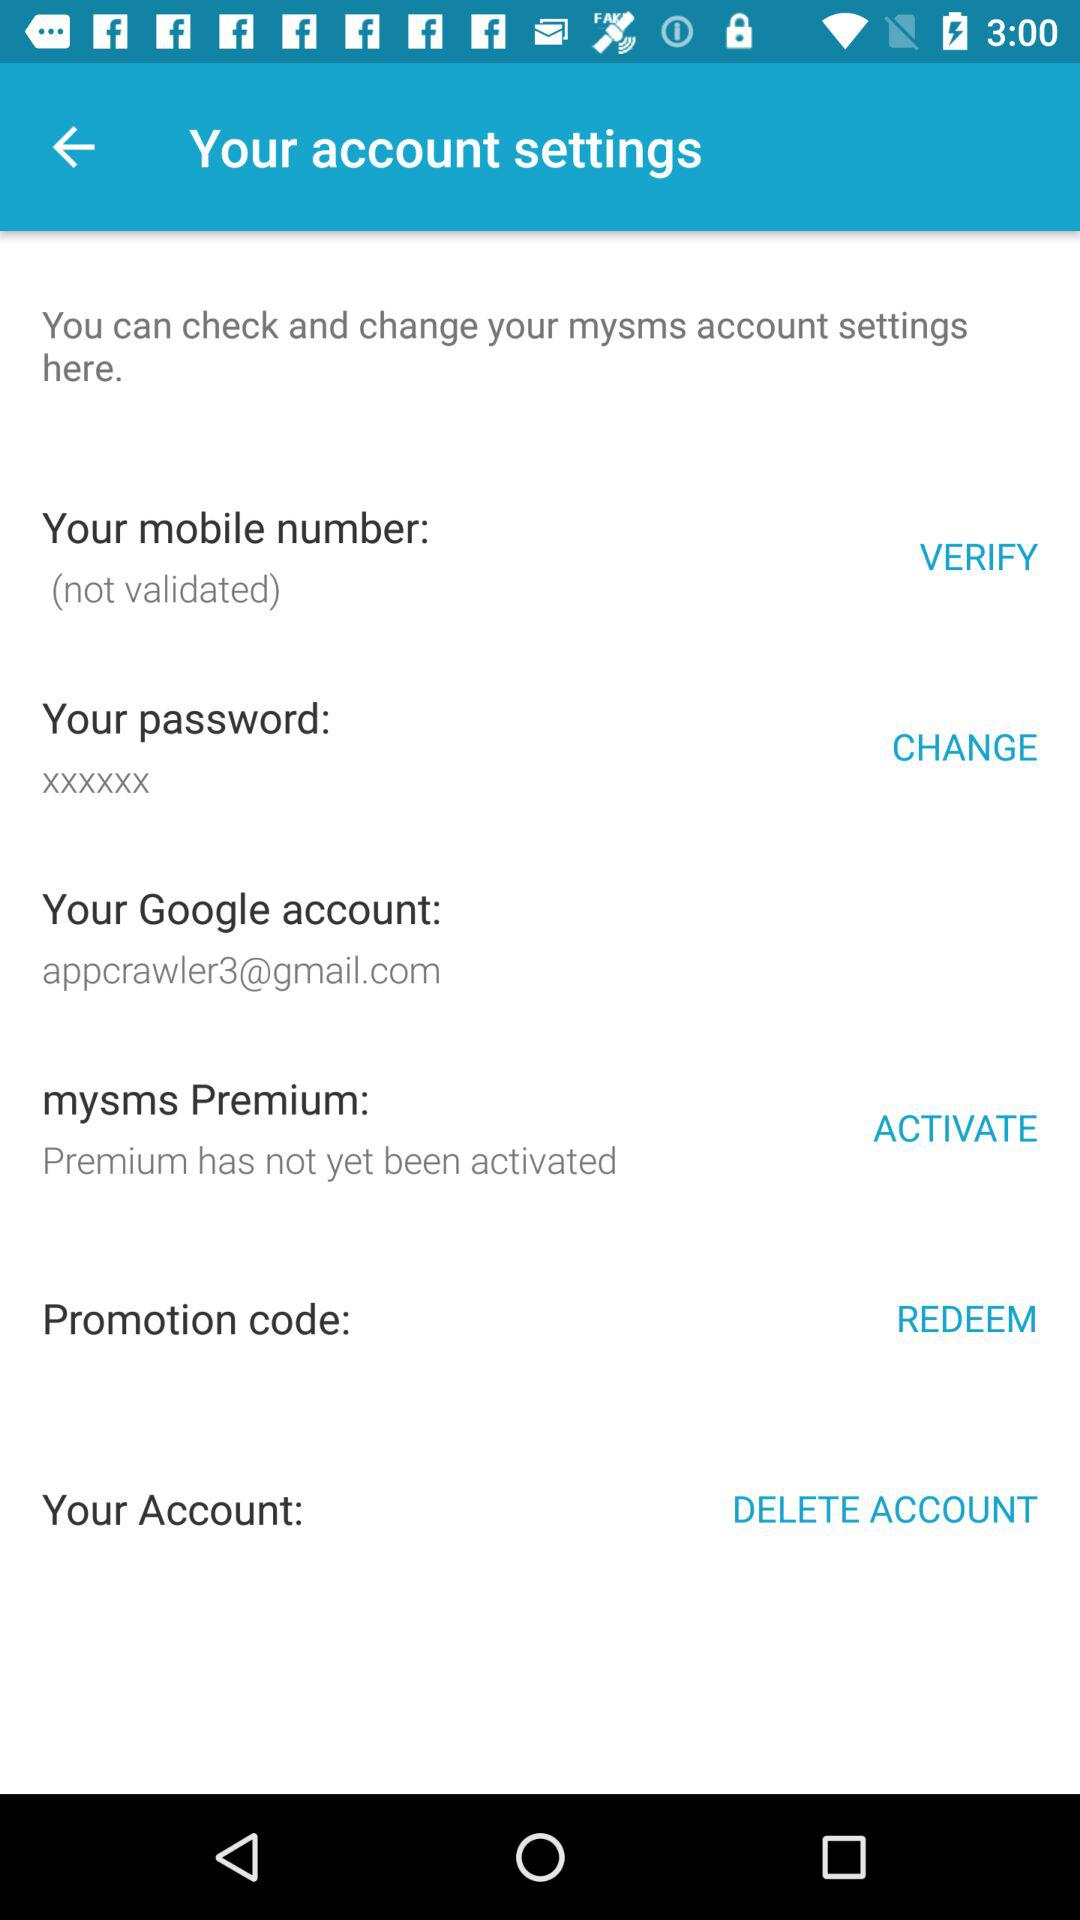What is the email address of the "Google" account? The email address is appcrawler3@gmail.com. 